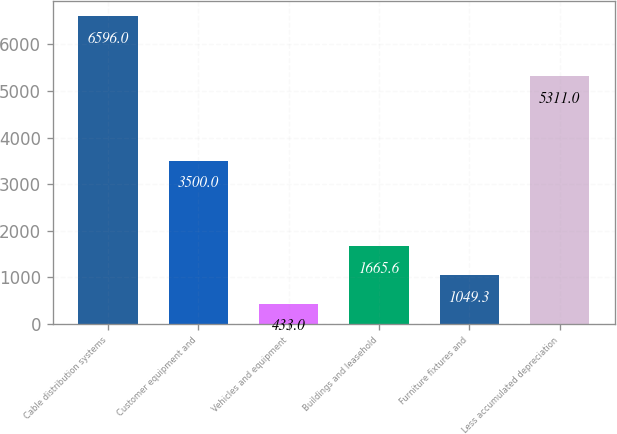Convert chart. <chart><loc_0><loc_0><loc_500><loc_500><bar_chart><fcel>Cable distribution systems<fcel>Customer equipment and<fcel>Vehicles and equipment<fcel>Buildings and leasehold<fcel>Furniture fixtures and<fcel>Less accumulated depreciation<nl><fcel>6596<fcel>3500<fcel>433<fcel>1665.6<fcel>1049.3<fcel>5311<nl></chart> 